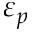Convert formula to latex. <formula><loc_0><loc_0><loc_500><loc_500>\varepsilon _ { p }</formula> 